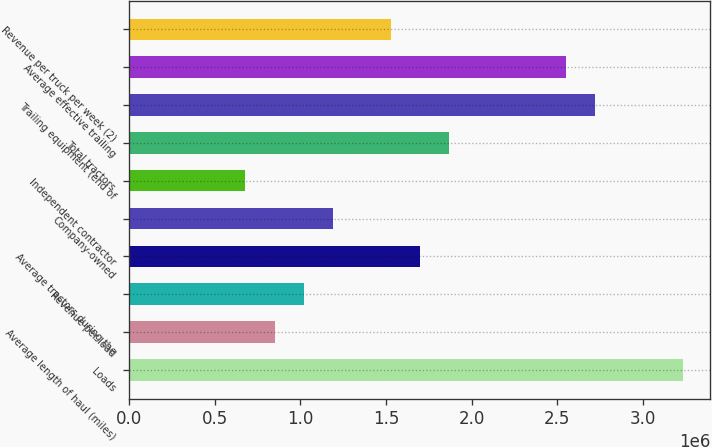Convert chart. <chart><loc_0><loc_0><loc_500><loc_500><bar_chart><fcel>Loads<fcel>Average length of haul (miles)<fcel>Revenue per load<fcel>Average tractors during the<fcel>Company-owned<fcel>Independent contractor<fcel>Total tractors<fcel>Trailing equipment (end of<fcel>Average effective trailing<fcel>Revenue per truck per week (2)<nl><fcel>3.2307e+06<fcel>850194<fcel>1.02023e+06<fcel>1.70037e+06<fcel>1.19027e+06<fcel>680157<fcel>1.87041e+06<fcel>2.72059e+06<fcel>2.55055e+06<fcel>1.53034e+06<nl></chart> 